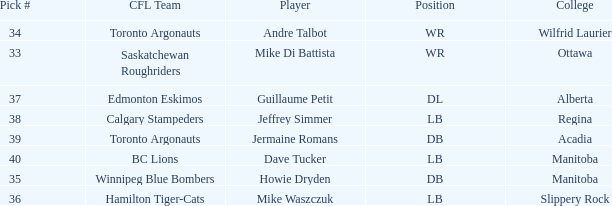What College has a Player that is jermaine romans? Acadia. 